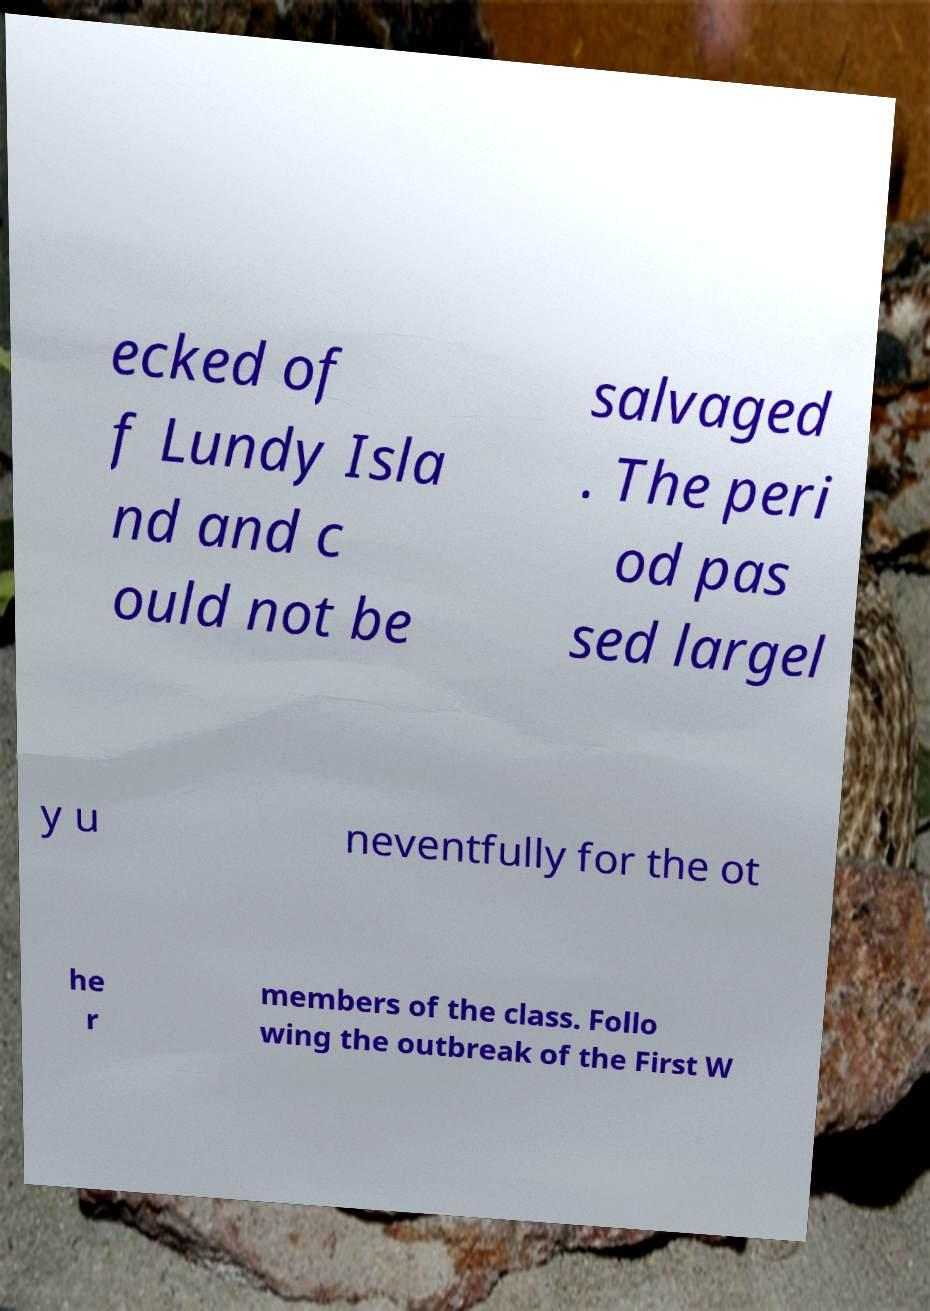Could you extract and type out the text from this image? ecked of f Lundy Isla nd and c ould not be salvaged . The peri od pas sed largel y u neventfully for the ot he r members of the class. Follo wing the outbreak of the First W 